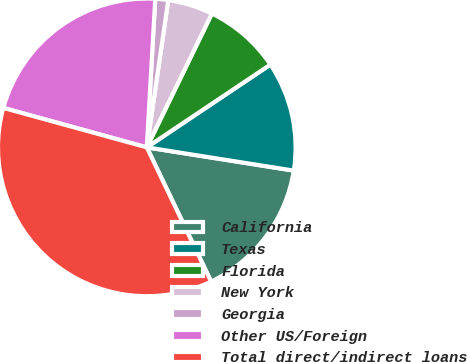Convert chart to OTSL. <chart><loc_0><loc_0><loc_500><loc_500><pie_chart><fcel>California<fcel>Texas<fcel>Florida<fcel>New York<fcel>Georgia<fcel>Other US/Foreign<fcel>Total direct/indirect loans<nl><fcel>15.39%<fcel>11.89%<fcel>8.4%<fcel>4.9%<fcel>1.4%<fcel>21.63%<fcel>36.38%<nl></chart> 